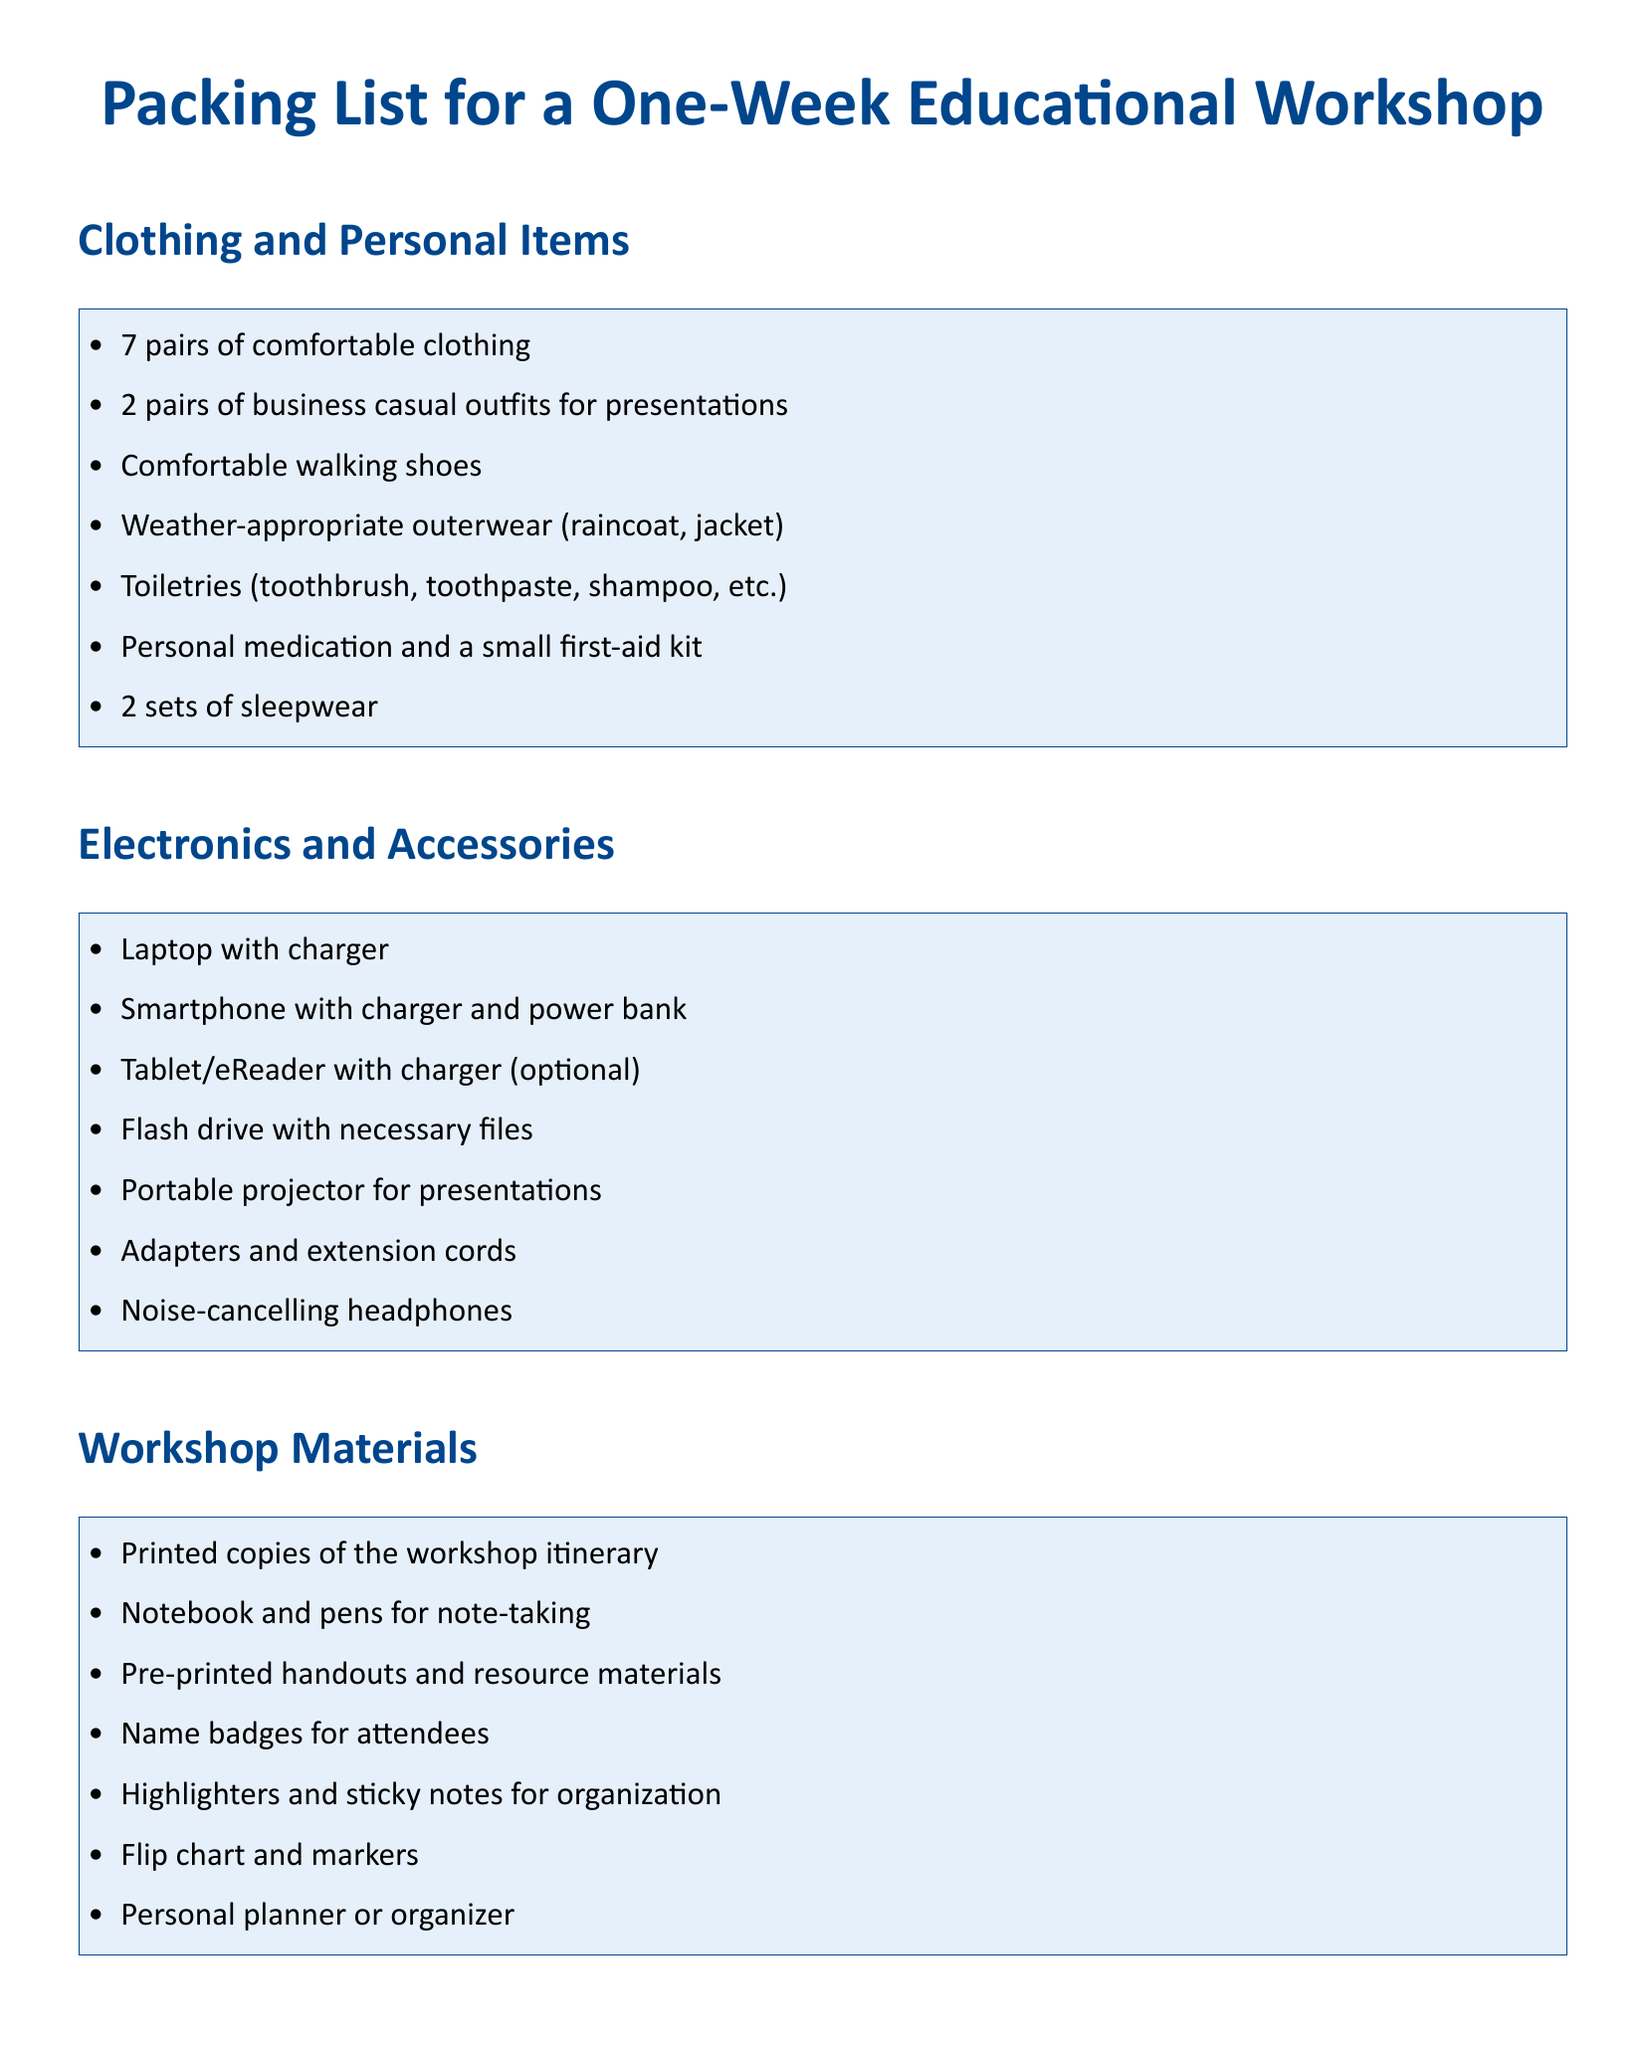What items are needed for sleepwear? The document specifies the need for 2 sets of sleepwear under personal items.
Answer: 2 sets How many days is the workshop scheduled for? The overview of daily agendas implies that the workshop lasts for 5 days.
Answer: 5 days What type of shoes are recommended? The document mentions comfortable walking shoes as part of the clothing list.
Answer: Comfortable walking shoes What is one of the topics covered on Day 2? The agenda lists Advanced Teaching Strategies as one of the topics on Day 2.
Answer: Advanced Teaching Strategies What device is optional according to the packing list? The packing list mentions a tablet/eReader as an optional device under electronics.
Answer: Tablet/eReader What should attendees have for note-taking? The workshop materials section specifies a notebook and pens for note-taking.
Answer: Notebook and pens What is included in the workshop materials for organization? The document lists highlighters and sticky notes for organization under workshop materials.
Answer: Highlighters and sticky notes What color is the document's title? The title section specifies the title is in dark blue color.
Answer: Dark blue What is the main focus of Day 3 in the agenda? The document outlines Classroom Management as a focus topic for Day 3.
Answer: Classroom Management 